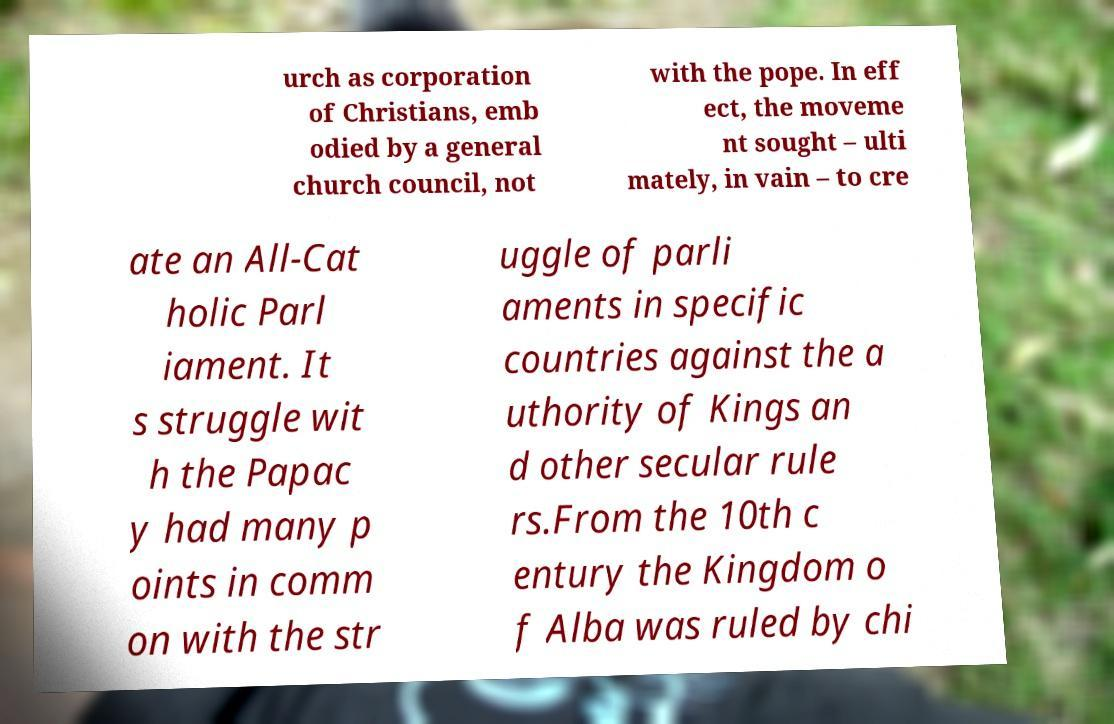Can you read and provide the text displayed in the image?This photo seems to have some interesting text. Can you extract and type it out for me? urch as corporation of Christians, emb odied by a general church council, not with the pope. In eff ect, the moveme nt sought – ulti mately, in vain – to cre ate an All-Cat holic Parl iament. It s struggle wit h the Papac y had many p oints in comm on with the str uggle of parli aments in specific countries against the a uthority of Kings an d other secular rule rs.From the 10th c entury the Kingdom o f Alba was ruled by chi 